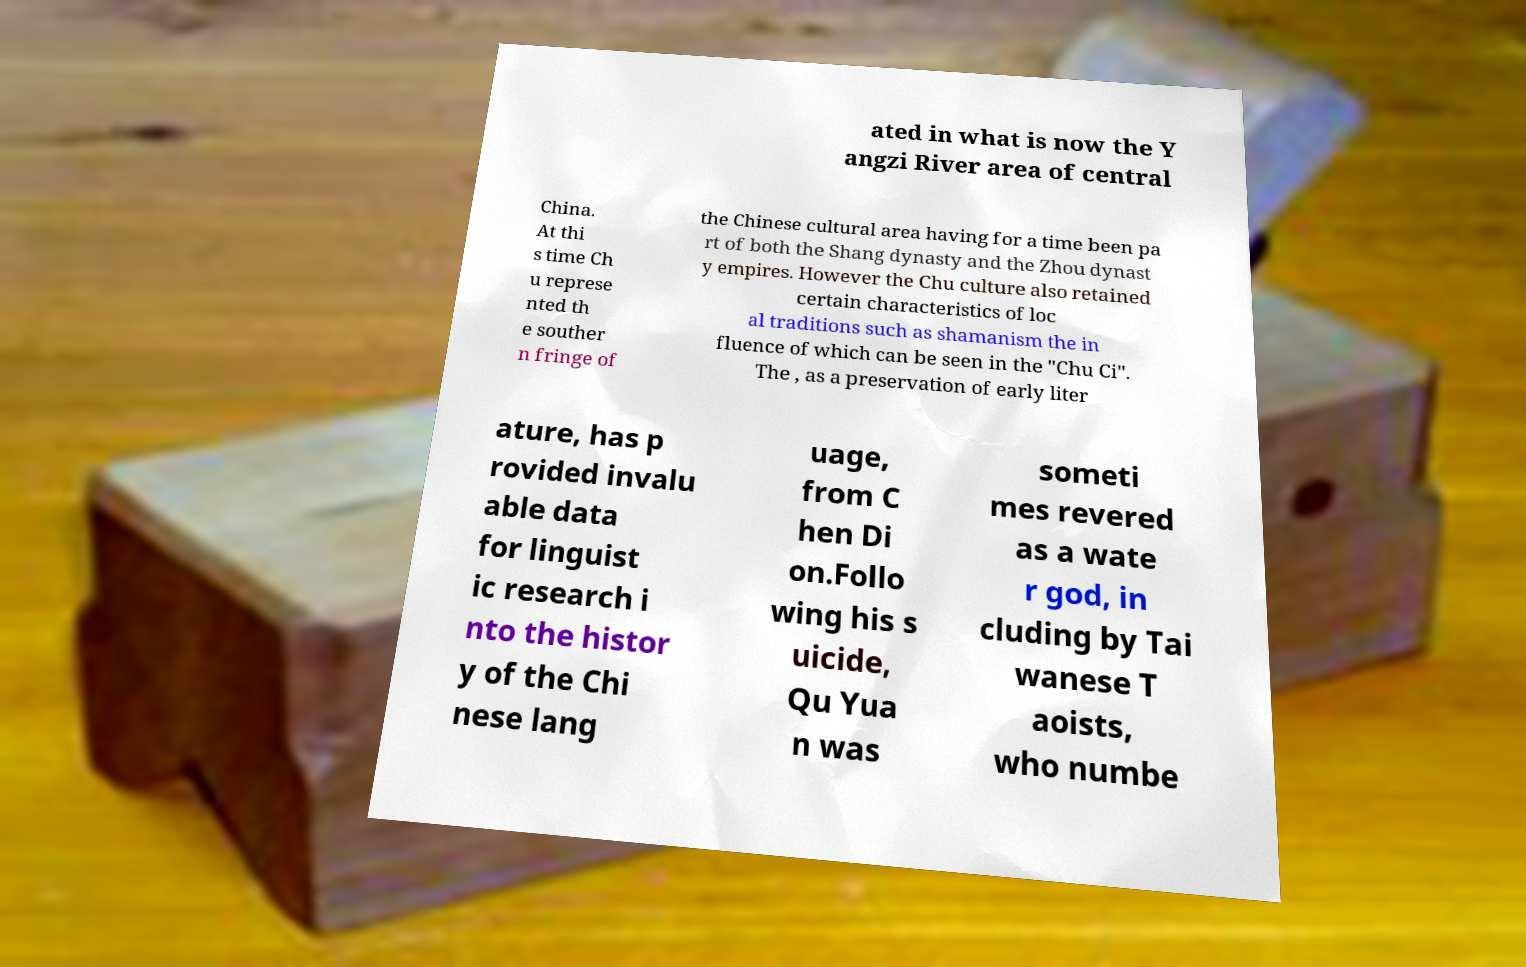Could you assist in decoding the text presented in this image and type it out clearly? ated in what is now the Y angzi River area of central China. At thi s time Ch u represe nted th e souther n fringe of the Chinese cultural area having for a time been pa rt of both the Shang dynasty and the Zhou dynast y empires. However the Chu culture also retained certain characteristics of loc al traditions such as shamanism the in fluence of which can be seen in the "Chu Ci". The , as a preservation of early liter ature, has p rovided invalu able data for linguist ic research i nto the histor y of the Chi nese lang uage, from C hen Di on.Follo wing his s uicide, Qu Yua n was someti mes revered as a wate r god, in cluding by Tai wanese T aoists, who numbe 